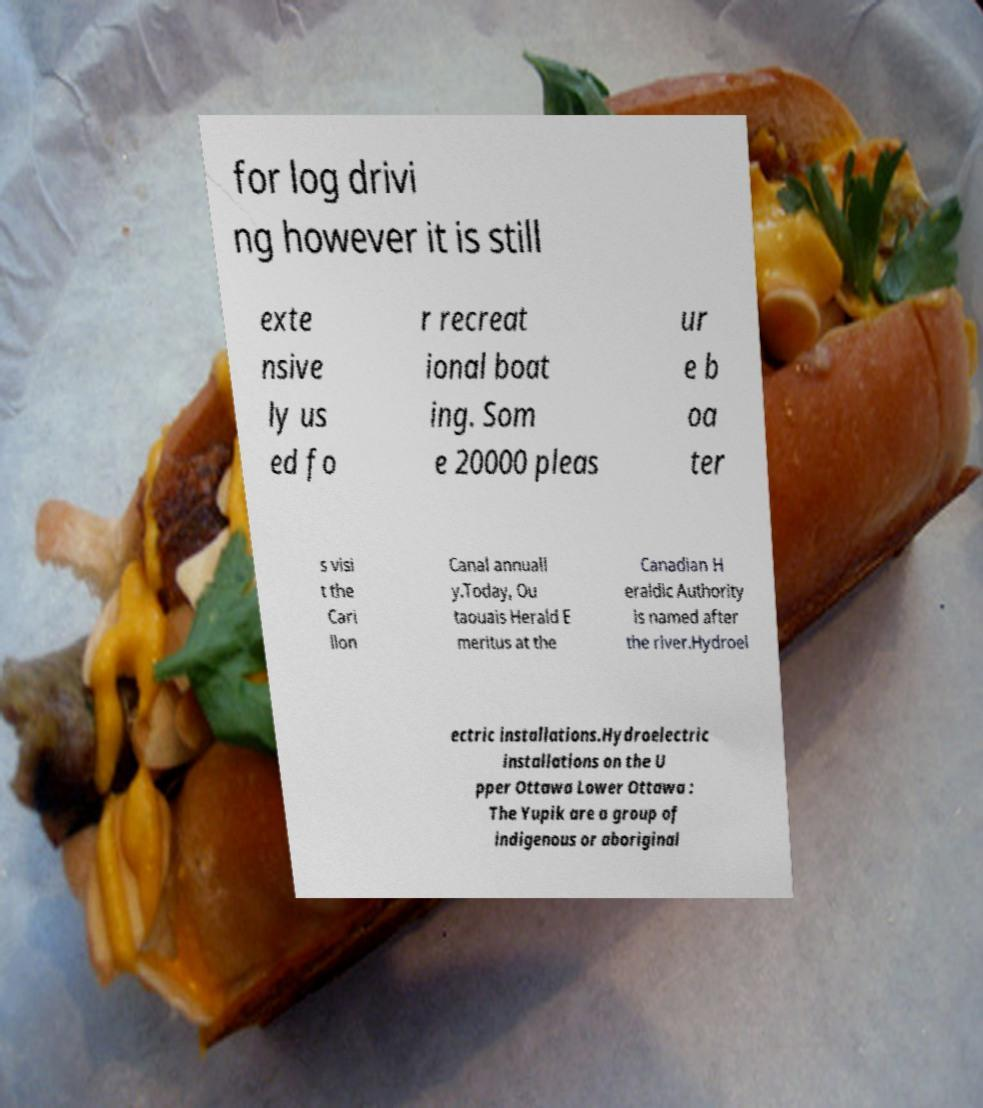There's text embedded in this image that I need extracted. Can you transcribe it verbatim? for log drivi ng however it is still exte nsive ly us ed fo r recreat ional boat ing. Som e 20000 pleas ur e b oa ter s visi t the Cari llon Canal annuall y.Today, Ou taouais Herald E meritus at the Canadian H eraldic Authority is named after the river.Hydroel ectric installations.Hydroelectric installations on the U pper Ottawa Lower Ottawa : The Yupik are a group of indigenous or aboriginal 